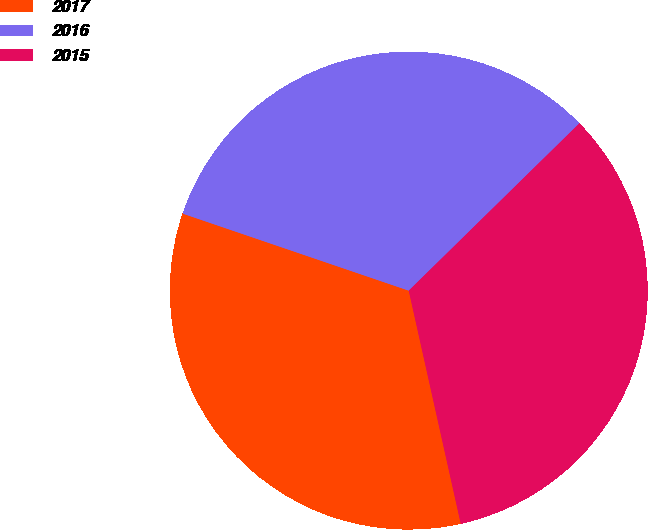<chart> <loc_0><loc_0><loc_500><loc_500><pie_chart><fcel>2017<fcel>2016<fcel>2015<nl><fcel>33.72%<fcel>32.43%<fcel>33.85%<nl></chart> 